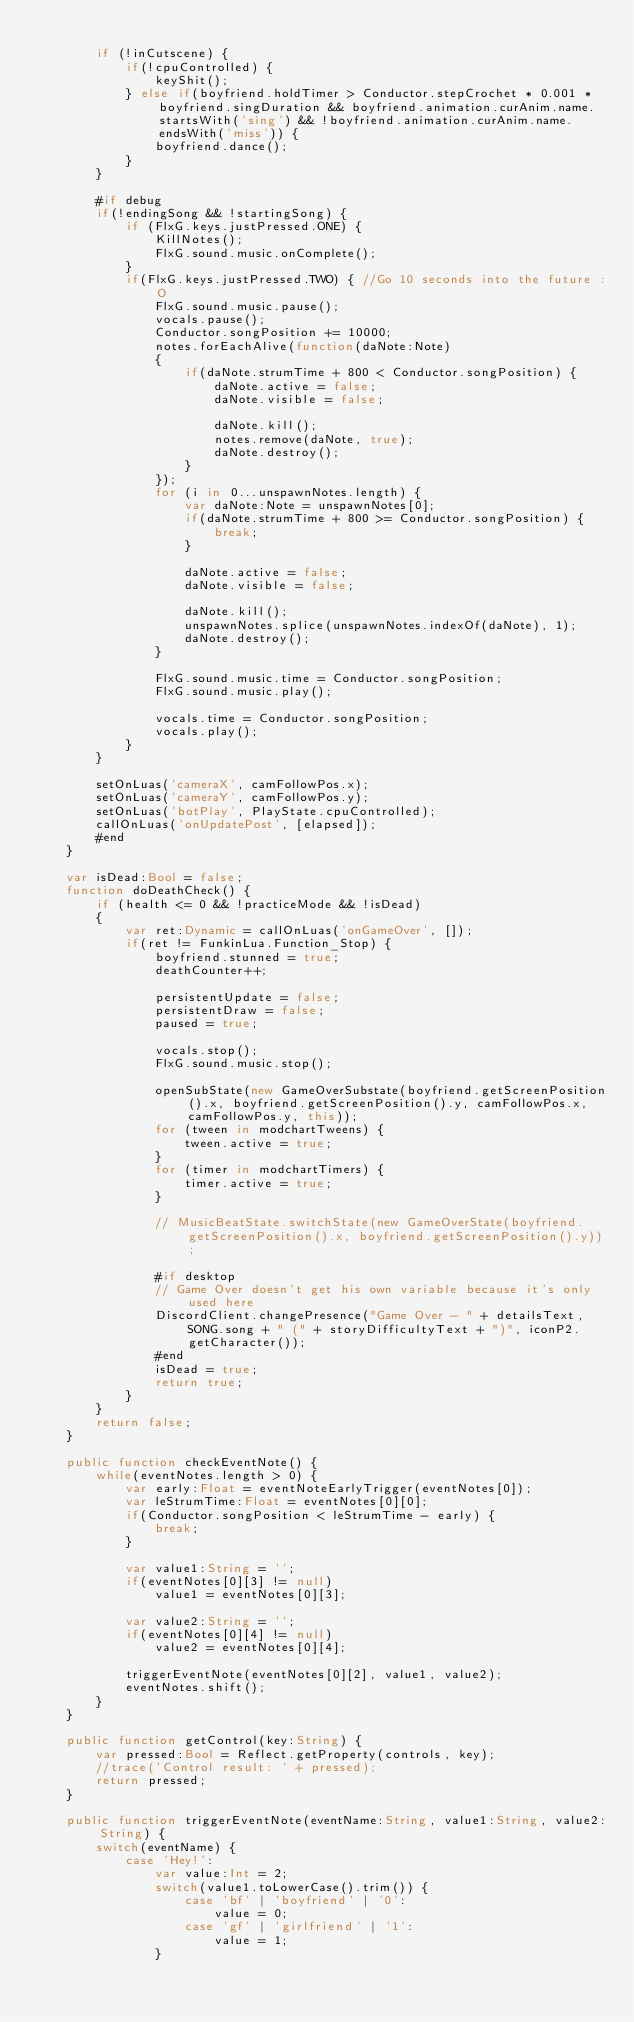Convert code to text. <code><loc_0><loc_0><loc_500><loc_500><_Haxe_>
		if (!inCutscene) {
			if(!cpuControlled) {
				keyShit();
			} else if(boyfriend.holdTimer > Conductor.stepCrochet * 0.001 * boyfriend.singDuration && boyfriend.animation.curAnim.name.startsWith('sing') && !boyfriend.animation.curAnim.name.endsWith('miss')) {
				boyfriend.dance();
			}
		}
		
		#if debug
		if(!endingSong && !startingSong) {
			if (FlxG.keys.justPressed.ONE) {
				KillNotes();
				FlxG.sound.music.onComplete();
			}
			if(FlxG.keys.justPressed.TWO) { //Go 10 seconds into the future :O
				FlxG.sound.music.pause();
				vocals.pause();
				Conductor.songPosition += 10000;
				notes.forEachAlive(function(daNote:Note)
				{
					if(daNote.strumTime + 800 < Conductor.songPosition) {
						daNote.active = false;
						daNote.visible = false;

						daNote.kill();
						notes.remove(daNote, true);
						daNote.destroy();
					}
				});
				for (i in 0...unspawnNotes.length) {
					var daNote:Note = unspawnNotes[0];
					if(daNote.strumTime + 800 >= Conductor.songPosition) {
						break;
					}

					daNote.active = false;
					daNote.visible = false;

					daNote.kill();
					unspawnNotes.splice(unspawnNotes.indexOf(daNote), 1);
					daNote.destroy();
				}

				FlxG.sound.music.time = Conductor.songPosition;
				FlxG.sound.music.play();

				vocals.time = Conductor.songPosition;
				vocals.play();
			}
		}

		setOnLuas('cameraX', camFollowPos.x);
		setOnLuas('cameraY', camFollowPos.y);
		setOnLuas('botPlay', PlayState.cpuControlled);
		callOnLuas('onUpdatePost', [elapsed]);
		#end
	}

	var isDead:Bool = false;
	function doDeathCheck() {
		if (health <= 0 && !practiceMode && !isDead)
		{
			var ret:Dynamic = callOnLuas('onGameOver', []);
			if(ret != FunkinLua.Function_Stop) {
				boyfriend.stunned = true;
				deathCounter++;

				persistentUpdate = false;
				persistentDraw = false;
				paused = true;

				vocals.stop();
				FlxG.sound.music.stop();

				openSubState(new GameOverSubstate(boyfriend.getScreenPosition().x, boyfriend.getScreenPosition().y, camFollowPos.x, camFollowPos.y, this));
				for (tween in modchartTweens) {
					tween.active = true;
				}
				for (timer in modchartTimers) {
					timer.active = true;
				}

				// MusicBeatState.switchState(new GameOverState(boyfriend.getScreenPosition().x, boyfriend.getScreenPosition().y));
				
				#if desktop
				// Game Over doesn't get his own variable because it's only used here
				DiscordClient.changePresence("Game Over - " + detailsText, SONG.song + " (" + storyDifficultyText + ")", iconP2.getCharacter());
				#end
				isDead = true;
				return true;
			}
		}
		return false;
	}

	public function checkEventNote() {
		while(eventNotes.length > 0) {
			var early:Float = eventNoteEarlyTrigger(eventNotes[0]);
			var leStrumTime:Float = eventNotes[0][0];
			if(Conductor.songPosition < leStrumTime - early) {
				break;
			}

			var value1:String = '';
			if(eventNotes[0][3] != null)
				value1 = eventNotes[0][3];

			var value2:String = '';
			if(eventNotes[0][4] != null)
				value2 = eventNotes[0][4];

			triggerEventNote(eventNotes[0][2], value1, value2);
			eventNotes.shift();
		}
	}

	public function getControl(key:String) {
		var pressed:Bool = Reflect.getProperty(controls, key);
		//trace('Control result: ' + pressed);
		return pressed;
	}

	public function triggerEventNote(eventName:String, value1:String, value2:String) {
		switch(eventName) {
			case 'Hey!':
				var value:Int = 2;
				switch(value1.toLowerCase().trim()) {
					case 'bf' | 'boyfriend' | '0':
						value = 0;
					case 'gf' | 'girlfriend' | '1':
						value = 1;
				}
</code> 